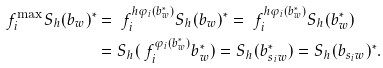Convert formula to latex. <formula><loc_0><loc_0><loc_500><loc_500>\ f _ { i } ^ { \max } S _ { h } ( b _ { w } ) ^ { * } & = \ f _ { i } ^ { h \varphi _ { i } ( b _ { w } ^ { * } ) } S _ { h } ( b _ { w } ) ^ { * } = \ f _ { i } ^ { h \varphi _ { i } ( b _ { w } ^ { * } ) } S _ { h } ( b _ { w } ^ { * } ) \\ & = S _ { h } ( \ f _ { i } ^ { \varphi _ { i } ( b _ { w } ^ { * } ) } b _ { w } ^ { * } ) = S _ { h } ( b _ { s _ { i } w } ^ { * } ) = S _ { h } ( b _ { s _ { i } w } ) ^ { * } .</formula> 